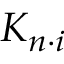<formula> <loc_0><loc_0><loc_500><loc_500>K _ { n \cdot i }</formula> 